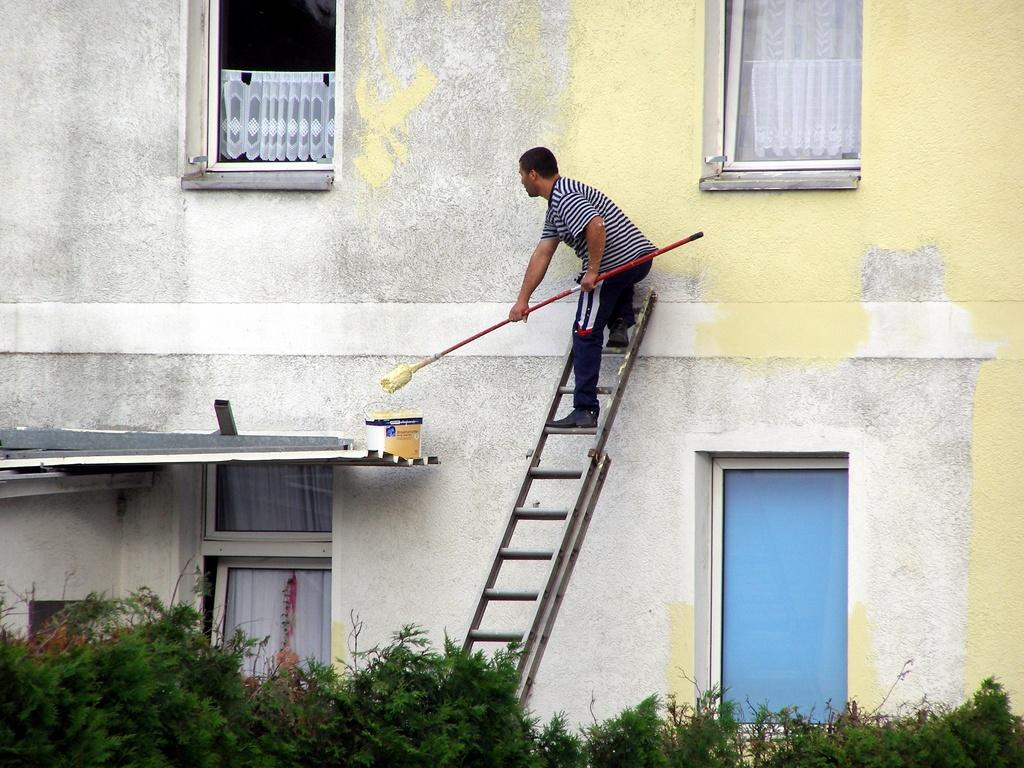What is the man in the image doing? The man is on a ladder and holding a broomstick. Where is the man located in the image? The man is on a ladder. What can be seen in the background of the image? There is a building, windows, curtains, a bucket, and trees in the background of the image. What type of discovery is the man making in the image? There is no indication of a discovery being made in the image. 